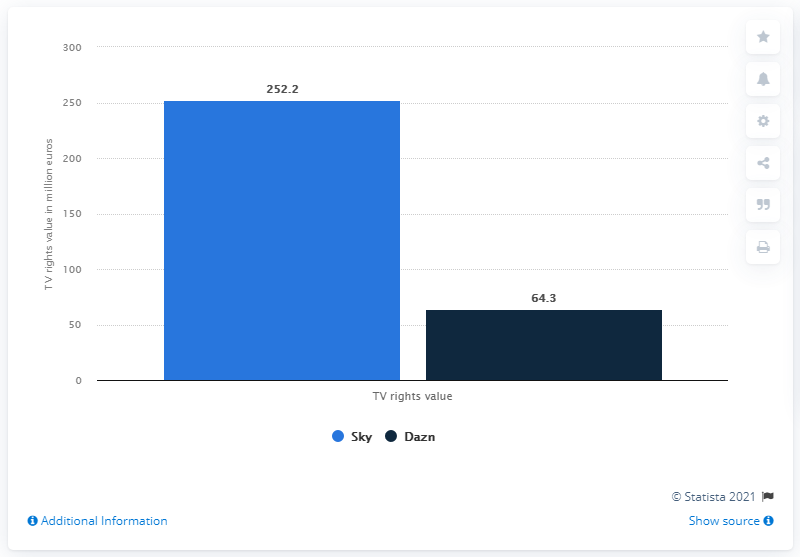Point out several critical features in this image. The value of the television rights for the 86 matches broadcast on Sky was 252.2 million dollars. 